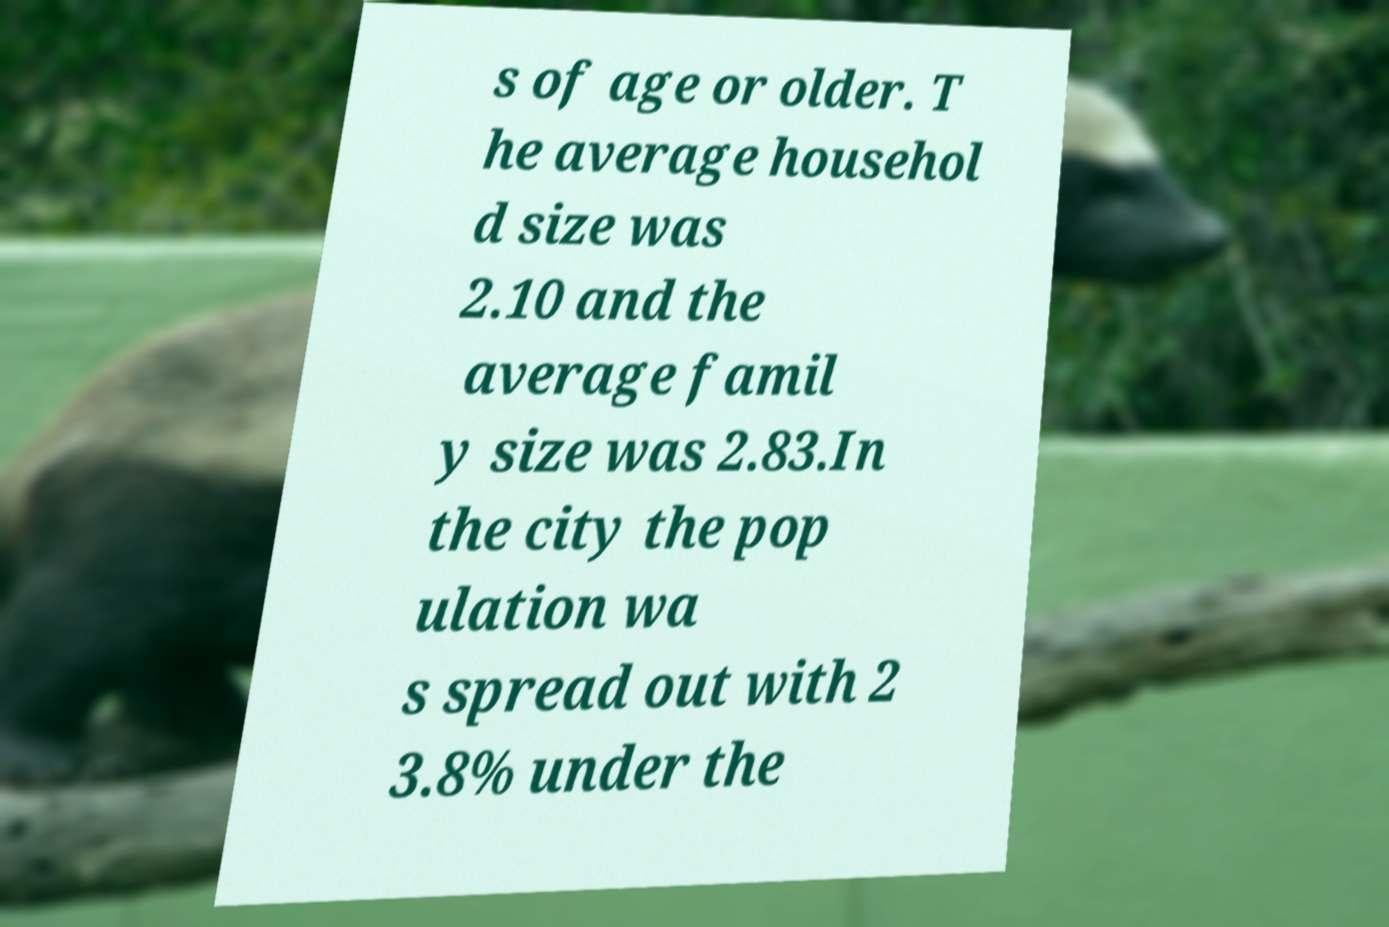Can you read and provide the text displayed in the image?This photo seems to have some interesting text. Can you extract and type it out for me? s of age or older. T he average househol d size was 2.10 and the average famil y size was 2.83.In the city the pop ulation wa s spread out with 2 3.8% under the 